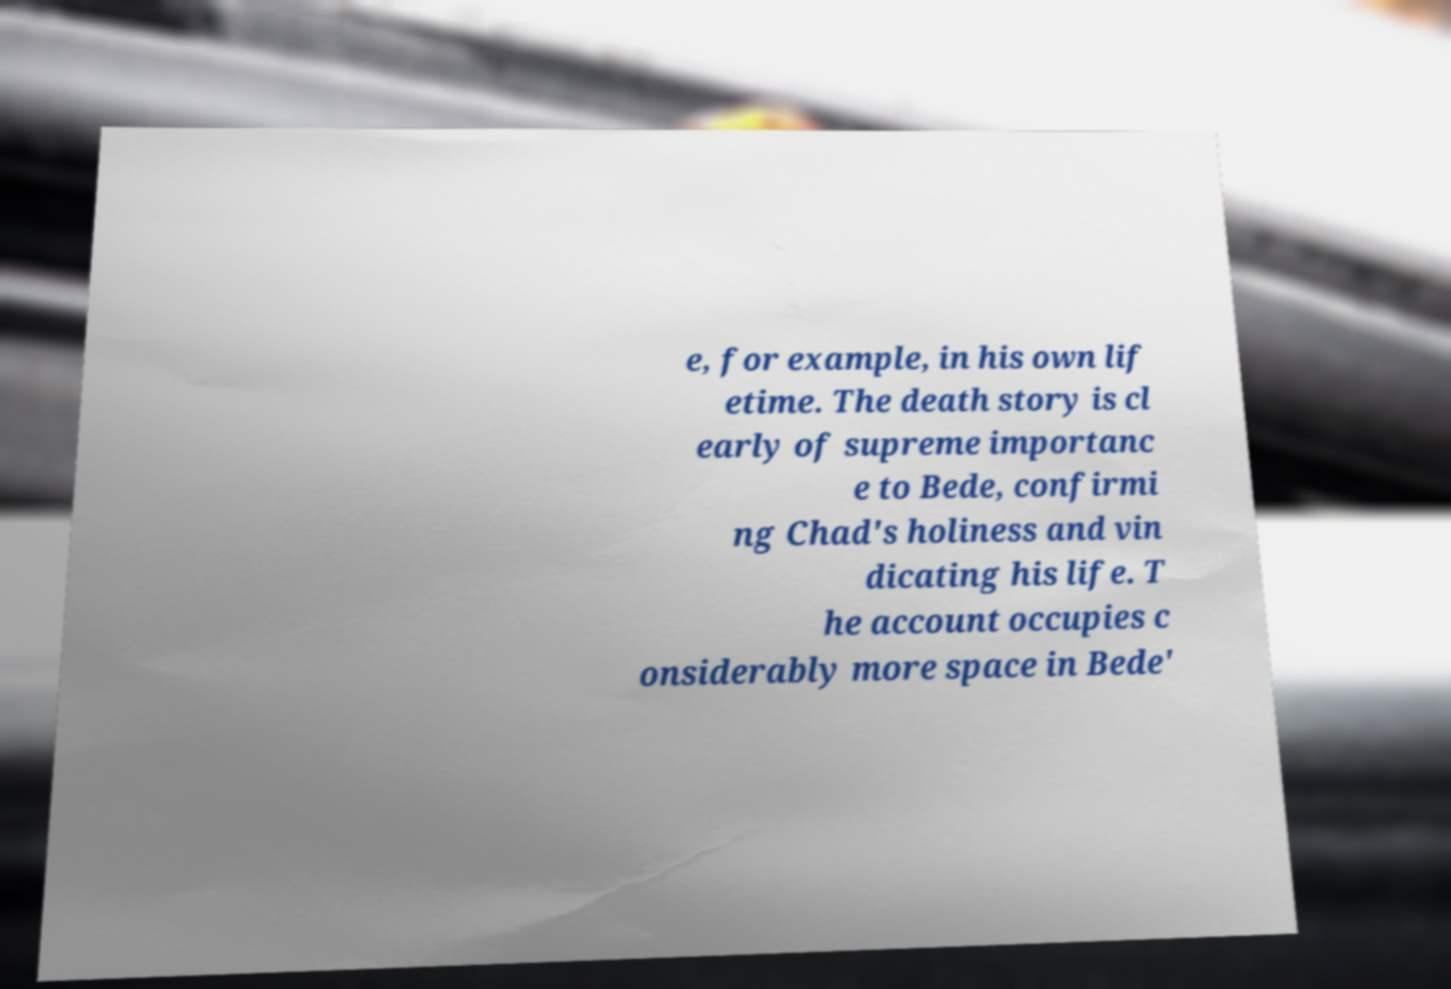Could you extract and type out the text from this image? e, for example, in his own lif etime. The death story is cl early of supreme importanc e to Bede, confirmi ng Chad's holiness and vin dicating his life. T he account occupies c onsiderably more space in Bede' 